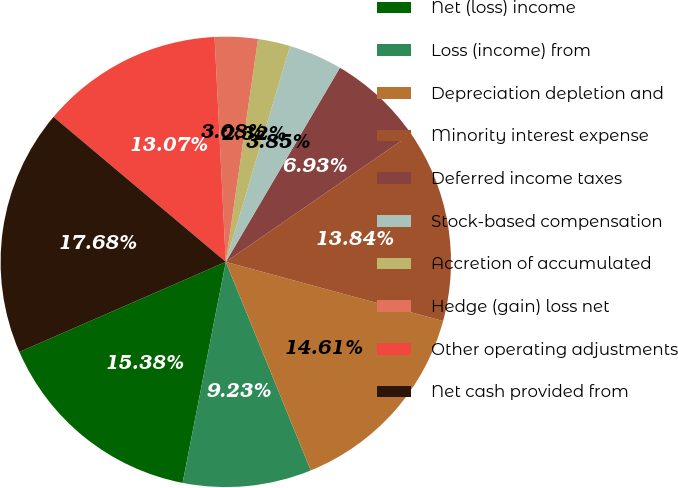Convert chart. <chart><loc_0><loc_0><loc_500><loc_500><pie_chart><fcel>Net (loss) income<fcel>Loss (income) from<fcel>Depreciation depletion and<fcel>Minority interest expense<fcel>Deferred income taxes<fcel>Stock-based compensation<fcel>Accretion of accumulated<fcel>Hedge (gain) loss net<fcel>Other operating adjustments<fcel>Net cash provided from<nl><fcel>15.38%<fcel>9.23%<fcel>14.61%<fcel>13.84%<fcel>6.93%<fcel>3.85%<fcel>2.32%<fcel>3.08%<fcel>13.07%<fcel>17.68%<nl></chart> 